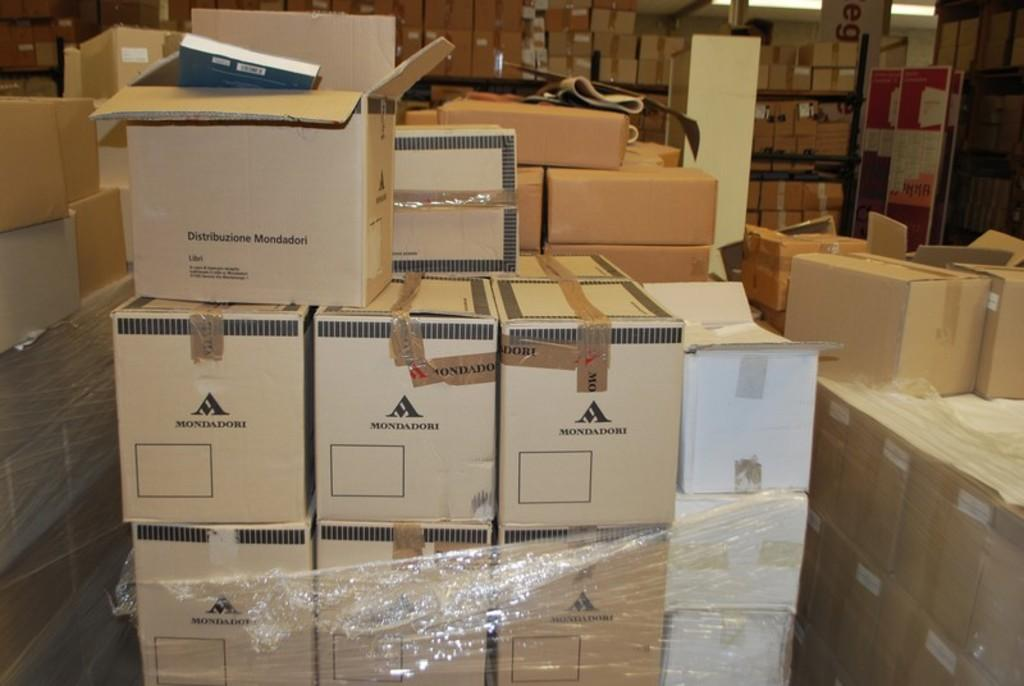<image>
Provide a brief description of the given image. Several boxes are sitting in a warehouse, some with Mondadori written on them. 